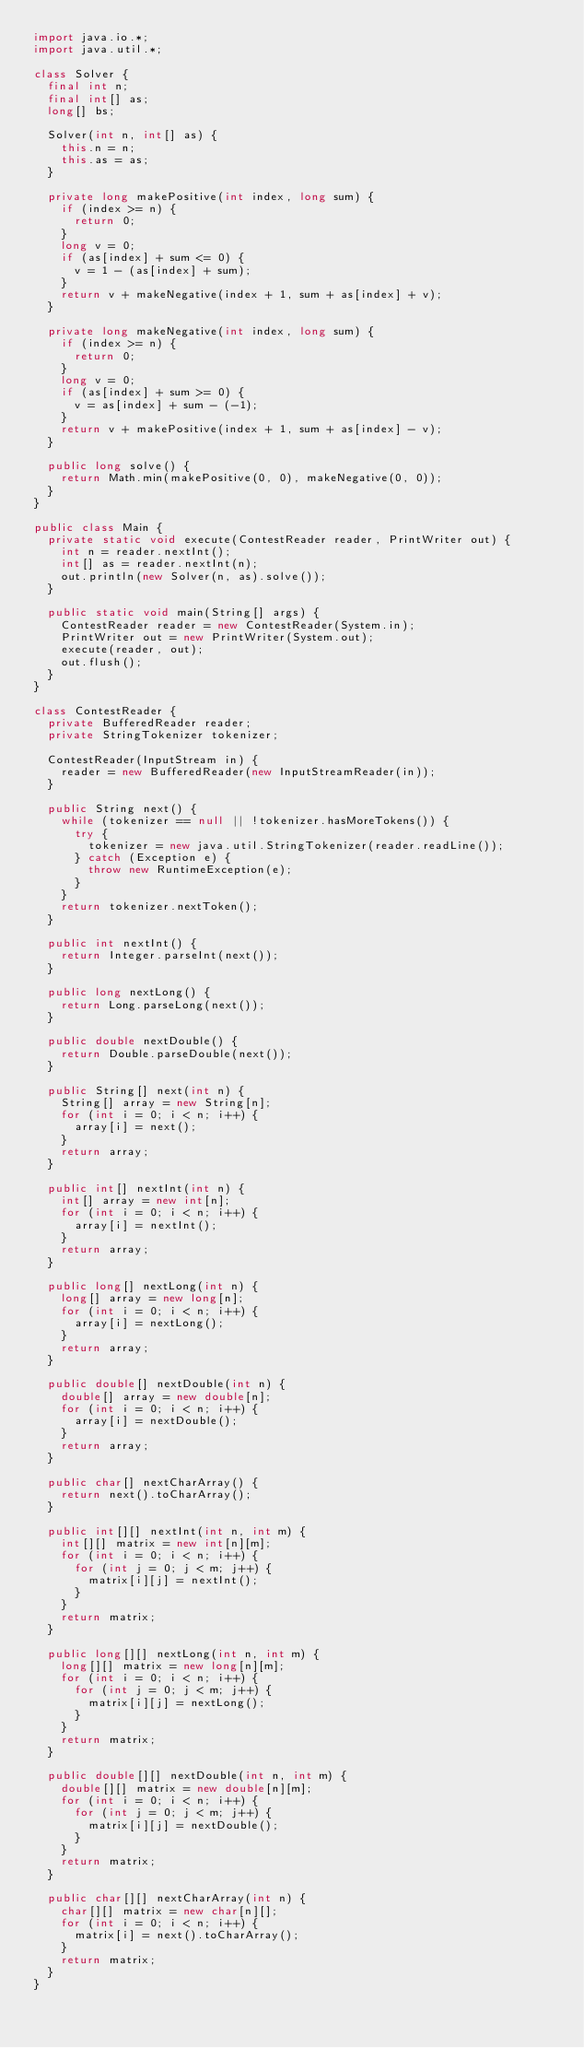<code> <loc_0><loc_0><loc_500><loc_500><_Java_>import java.io.*;
import java.util.*;

class Solver {
  final int n;
  final int[] as;
  long[] bs;
  
  Solver(int n, int[] as) {
    this.n = n;
    this.as = as;
  }
  
  private long makePositive(int index, long sum) {
    if (index >= n) {
      return 0;
    }
    long v = 0;
    if (as[index] + sum <= 0) {
      v = 1 - (as[index] + sum);
    }
    return v + makeNegative(index + 1, sum + as[index] + v);
  }
  
  private long makeNegative(int index, long sum) {
    if (index >= n) {
      return 0;
    }
    long v = 0;
    if (as[index] + sum >= 0) {
      v = as[index] + sum - (-1);
    }
    return v + makePositive(index + 1, sum + as[index] - v);
  }
  
  public long solve() {
    return Math.min(makePositive(0, 0), makeNegative(0, 0));
  }
}

public class Main {
  private static void execute(ContestReader reader, PrintWriter out) {
    int n = reader.nextInt();
    int[] as = reader.nextInt(n);
    out.println(new Solver(n, as).solve());
  }
  
  public static void main(String[] args) {
    ContestReader reader = new ContestReader(System.in);
    PrintWriter out = new PrintWriter(System.out);
    execute(reader, out);
    out.flush();
  }
}

class ContestReader {
  private BufferedReader reader;
  private StringTokenizer tokenizer;
  
  ContestReader(InputStream in) {
    reader = new BufferedReader(new InputStreamReader(in));
  }
  
  public String next() {
    while (tokenizer == null || !tokenizer.hasMoreTokens()) {
      try {
        tokenizer = new java.util.StringTokenizer(reader.readLine());
      } catch (Exception e) {
        throw new RuntimeException(e);
      }
    }
    return tokenizer.nextToken();
  }
  
  public int nextInt() {
    return Integer.parseInt(next());
  }
  
  public long nextLong() {
    return Long.parseLong(next());
  }
  
  public double nextDouble() {
    return Double.parseDouble(next());
  }
  
  public String[] next(int n) {
    String[] array = new String[n];
    for (int i = 0; i < n; i++) {
      array[i] = next();
    }
    return array;
  }
  
  public int[] nextInt(int n) {
    int[] array = new int[n];
    for (int i = 0; i < n; i++) {
      array[i] = nextInt();
    }
    return array;
  }
  
  public long[] nextLong(int n) {
    long[] array = new long[n];
    for (int i = 0; i < n; i++) {
      array[i] = nextLong();
    }
    return array;
  }
  
  public double[] nextDouble(int n) {
    double[] array = new double[n];
    for (int i = 0; i < n; i++) {
      array[i] = nextDouble();
    }
    return array;
  }
  
  public char[] nextCharArray() {
    return next().toCharArray();
  }
  
  public int[][] nextInt(int n, int m) {
    int[][] matrix = new int[n][m];
    for (int i = 0; i < n; i++) {
      for (int j = 0; j < m; j++) {
        matrix[i][j] = nextInt();
      }
    }
    return matrix;
  }
  
  public long[][] nextLong(int n, int m) {
    long[][] matrix = new long[n][m];
    for (int i = 0; i < n; i++) {
      for (int j = 0; j < m; j++) {
        matrix[i][j] = nextLong();
      }
    }
    return matrix;
  }
  
  public double[][] nextDouble(int n, int m) {
    double[][] matrix = new double[n][m];
    for (int i = 0; i < n; i++) {
      for (int j = 0; j < m; j++) {
        matrix[i][j] = nextDouble();
      }
    }
    return matrix;
  }
  
  public char[][] nextCharArray(int n) {
    char[][] matrix = new char[n][];
    for (int i = 0; i < n; i++) {
      matrix[i] = next().toCharArray();
    }
    return matrix;
  }
}
</code> 